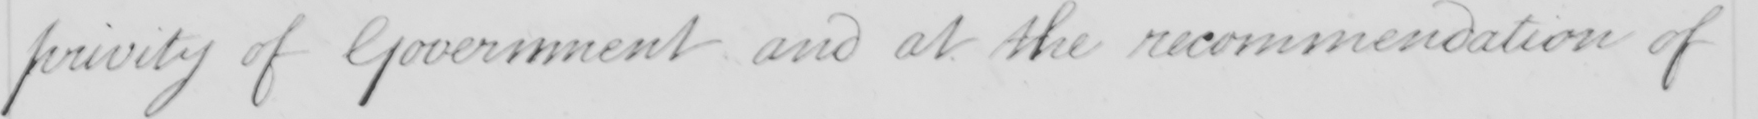What does this handwritten line say? privit of Government and at the recommendation of 